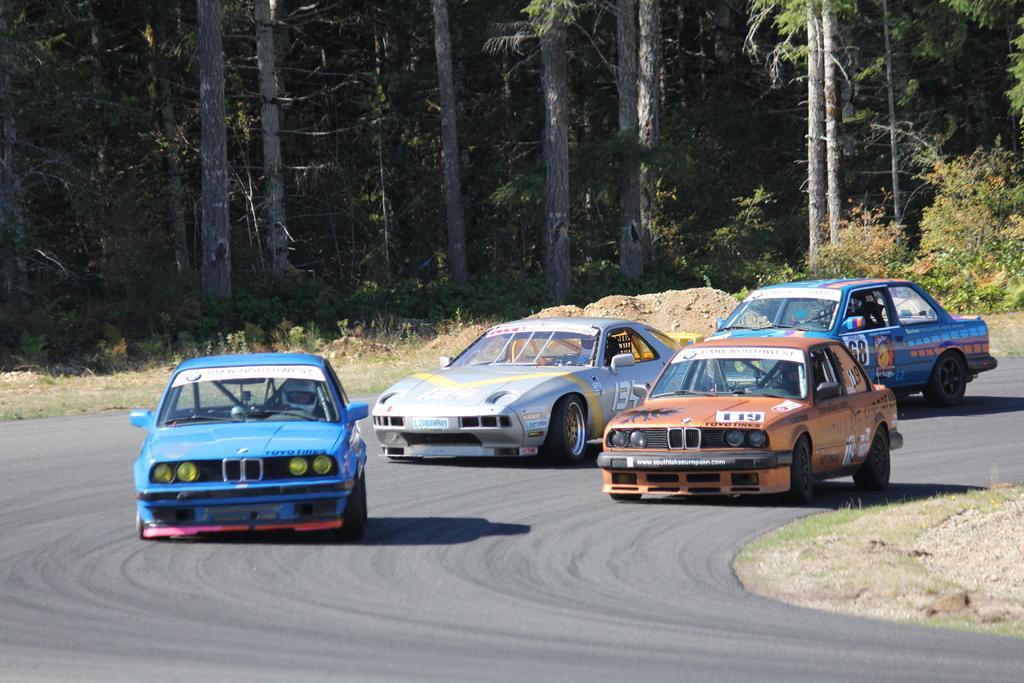Please provide a concise description of this image. In this image, we can see few people are riding cars on the road. Background we can see trees, plants and grass. 